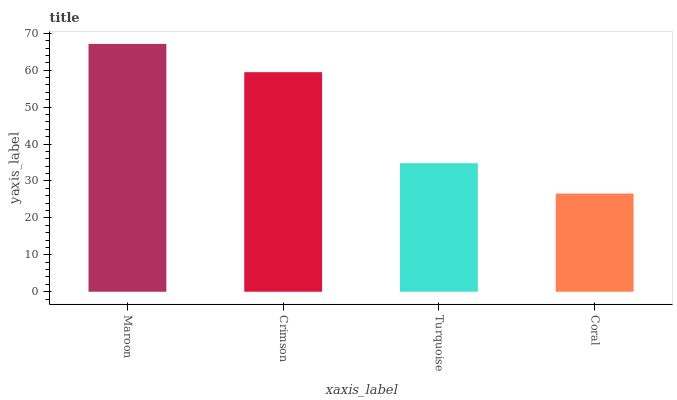Is Coral the minimum?
Answer yes or no. Yes. Is Maroon the maximum?
Answer yes or no. Yes. Is Crimson the minimum?
Answer yes or no. No. Is Crimson the maximum?
Answer yes or no. No. Is Maroon greater than Crimson?
Answer yes or no. Yes. Is Crimson less than Maroon?
Answer yes or no. Yes. Is Crimson greater than Maroon?
Answer yes or no. No. Is Maroon less than Crimson?
Answer yes or no. No. Is Crimson the high median?
Answer yes or no. Yes. Is Turquoise the low median?
Answer yes or no. Yes. Is Coral the high median?
Answer yes or no. No. Is Maroon the low median?
Answer yes or no. No. 